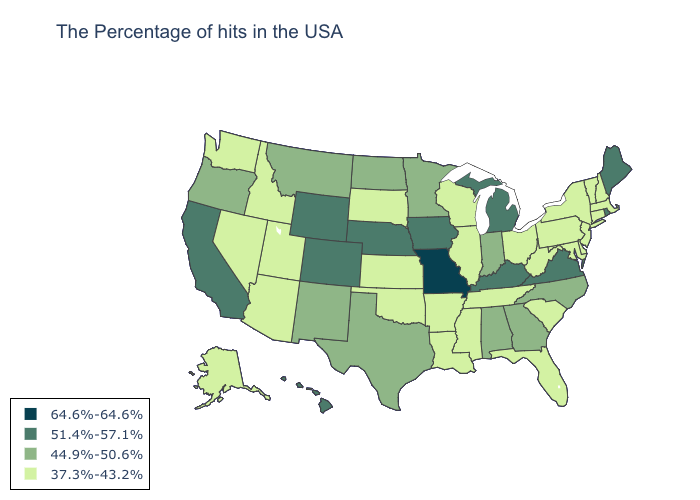Name the states that have a value in the range 64.6%-64.6%?
Keep it brief. Missouri. Does Alaska have the lowest value in the West?
Answer briefly. Yes. Name the states that have a value in the range 51.4%-57.1%?
Keep it brief. Maine, Rhode Island, Virginia, Michigan, Kentucky, Iowa, Nebraska, Wyoming, Colorado, California, Hawaii. Name the states that have a value in the range 51.4%-57.1%?
Concise answer only. Maine, Rhode Island, Virginia, Michigan, Kentucky, Iowa, Nebraska, Wyoming, Colorado, California, Hawaii. What is the value of Colorado?
Answer briefly. 51.4%-57.1%. What is the highest value in states that border Oregon?
Answer briefly. 51.4%-57.1%. What is the value of Nevada?
Be succinct. 37.3%-43.2%. Among the states that border Nevada , does Oregon have the lowest value?
Be succinct. No. What is the value of Minnesota?
Write a very short answer. 44.9%-50.6%. Which states have the highest value in the USA?
Concise answer only. Missouri. Which states hav the highest value in the West?
Answer briefly. Wyoming, Colorado, California, Hawaii. Does Ohio have a lower value than Pennsylvania?
Write a very short answer. No. Among the states that border Utah , which have the highest value?
Short answer required. Wyoming, Colorado. What is the value of Wisconsin?
Short answer required. 37.3%-43.2%. What is the value of Iowa?
Answer briefly. 51.4%-57.1%. 